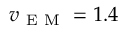Convert formula to latex. <formula><loc_0><loc_0><loc_500><loc_500>v _ { E M } = 1 . 4</formula> 